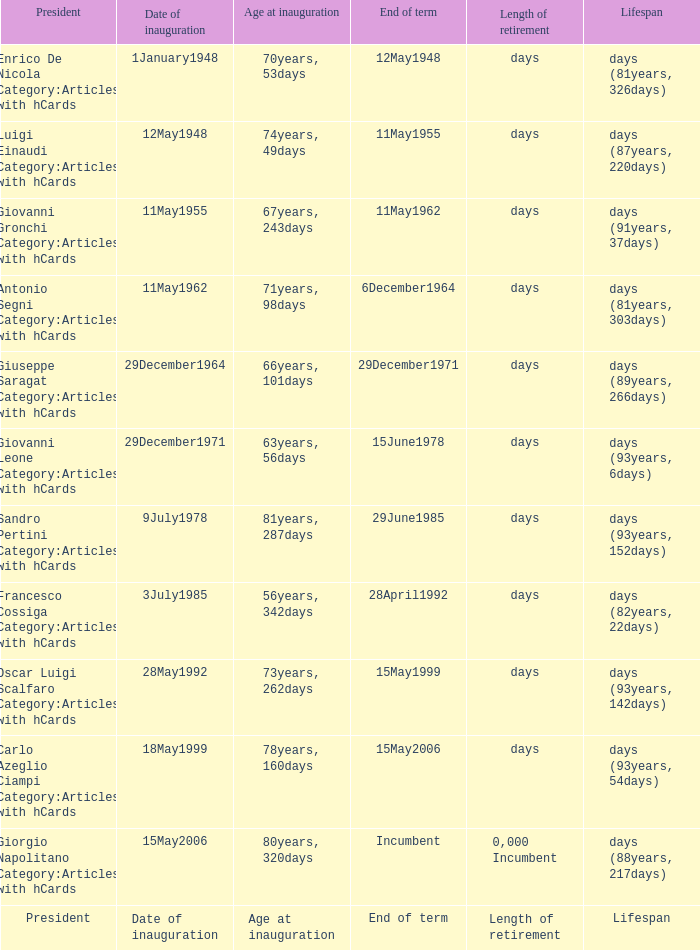What is the Date of inauguration of the President with an Age at inauguration of 73years, 262days? 28May1992. 